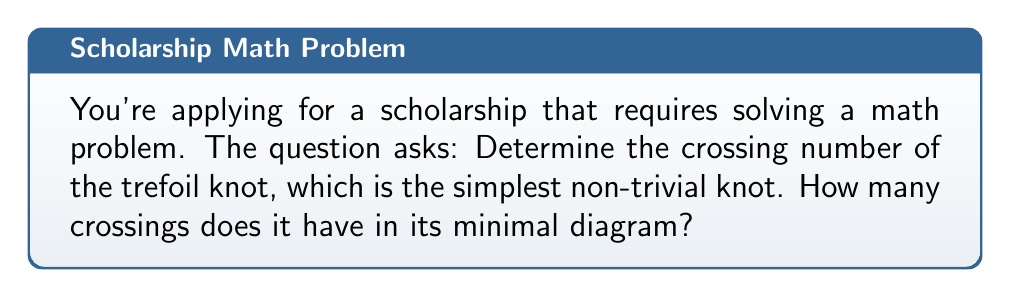Can you solve this math problem? Let's approach this step-by-step:

1) First, we need to understand what a trefoil knot is. It's the simplest non-trivial knot, often represented as a three-lobed curve.

2) The crossing number of a knot is the minimum number of crossings that occur in any diagram of the knot.

3) To visualize the trefoil knot, we can draw it:

[asy]
import geometry;

path p = (0,0)..(-1,1)..(0,2)..(1,1)..(0,0)..(1,-1)..(2,0)..(1,1);
draw(p, linewidth(1));

dot((0.33,0.33));
dot((1,1));
dot((0.67,0.67));

label("1", (0.33,0.33), SW);
label("2", (1,1), NE);
label("3", (0.67,0.67), SE);
[/asy]

4) In this diagram, we can clearly see that there are 3 crossings, labeled 1, 2, and 3.

5) The question is whether this is the minimal diagram. In knot theory, it's proven that the trefoil knot cannot be represented with fewer than 3 crossings.

6) Any attempt to reduce the number of crossings would either unknot the trefoil (making it a trivial knot) or create a different knot.

Therefore, the crossing number of the trefoil knot is 3.
Answer: 3 